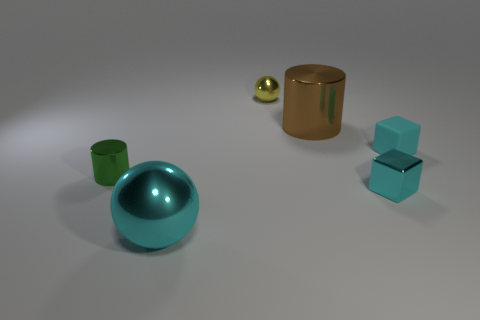Add 2 large brown matte cylinders. How many objects exist? 8 Subtract all cylinders. How many objects are left? 4 Add 2 green shiny things. How many green shiny things exist? 3 Subtract all cyan spheres. How many spheres are left? 1 Subtract 0 red cylinders. How many objects are left? 6 Subtract 1 blocks. How many blocks are left? 1 Subtract all gray cylinders. Subtract all green spheres. How many cylinders are left? 2 Subtract all green spheres. How many green blocks are left? 0 Subtract all small red matte cylinders. Subtract all green objects. How many objects are left? 5 Add 4 cylinders. How many cylinders are left? 6 